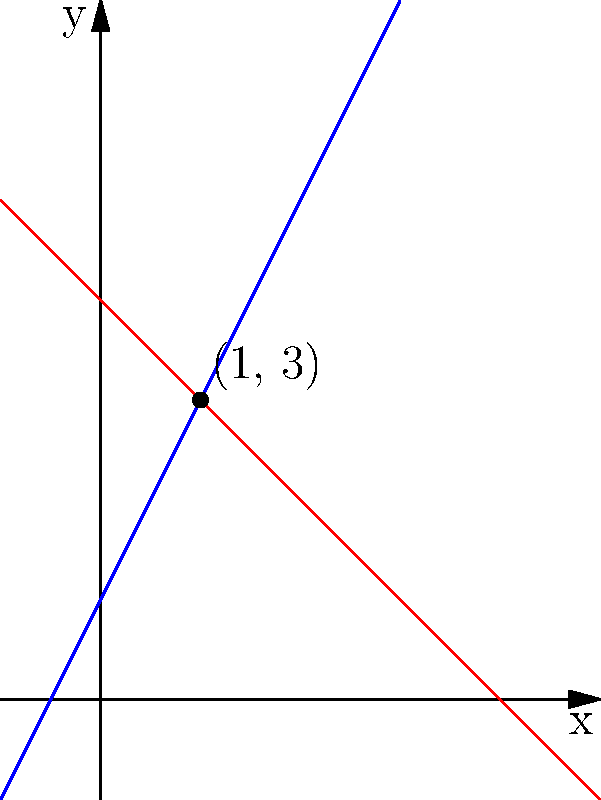In a Kotlin program, you need to find the intersection point of two lines given their equations: $y = 2x + 1$ and $y = -x + 4$. Write a function that returns the $x$ and $y$ coordinates of the intersection point as a Pair. What is the intersection point? To find the intersection point, we need to solve the system of equations:

$$\begin{cases}
y = 2x + 1 \\
y = -x + 4
\end{cases}$$

Step 1: Set the equations equal to each other
$2x + 1 = -x + 4$

Step 2: Solve for $x$
$2x + x = 4 - 1$
$3x = 3$
$x = 1$

Step 3: Substitute $x = 1$ into either equation to find $y$
Using $y = 2x + 1$:
$y = 2(1) + 1 = 3$

Step 4: The intersection point is $(1, 3)$

In Kotlin, you would implement this as:

```kotlin
fun findIntersection(): Pair<Double, Double> {
    val x = 1.0
    val y = 2 * x + 1
    return Pair(x, y)
}
```
Answer: (1.0, 3.0) 